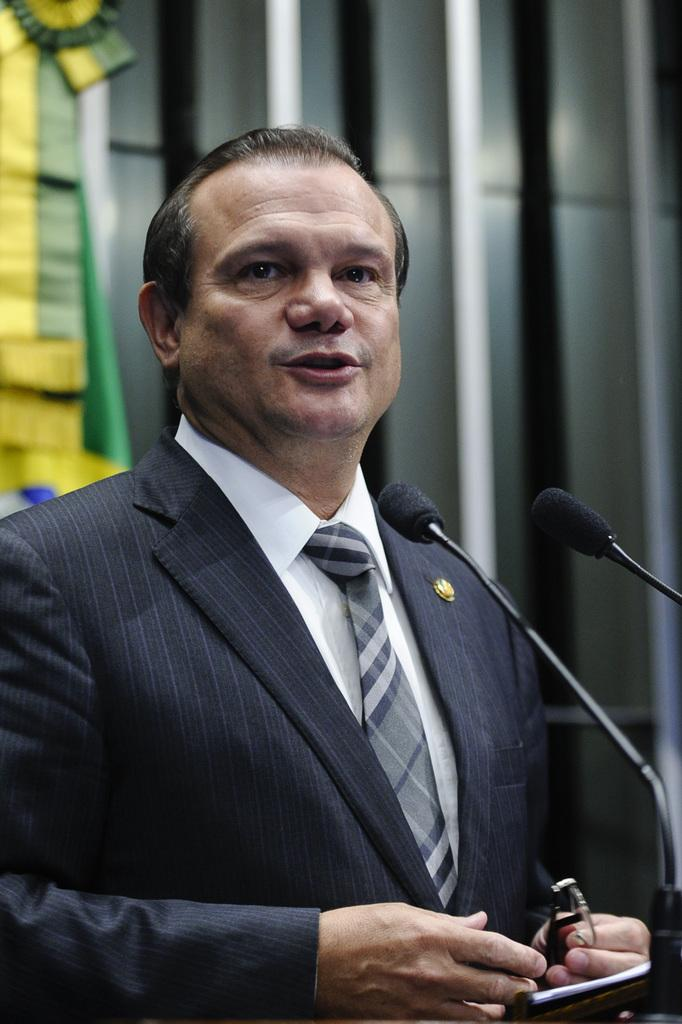Who is the main subject in the image? There is a man in the image. Where is the man located in the image? The man is standing on a stage. What is the man doing in the image? The man is speaking into a microphone. What type of jam is the man spreading on the bread in the image? There is no jam or bread present in the image; the man is speaking into a microphone while standing on a stage. 